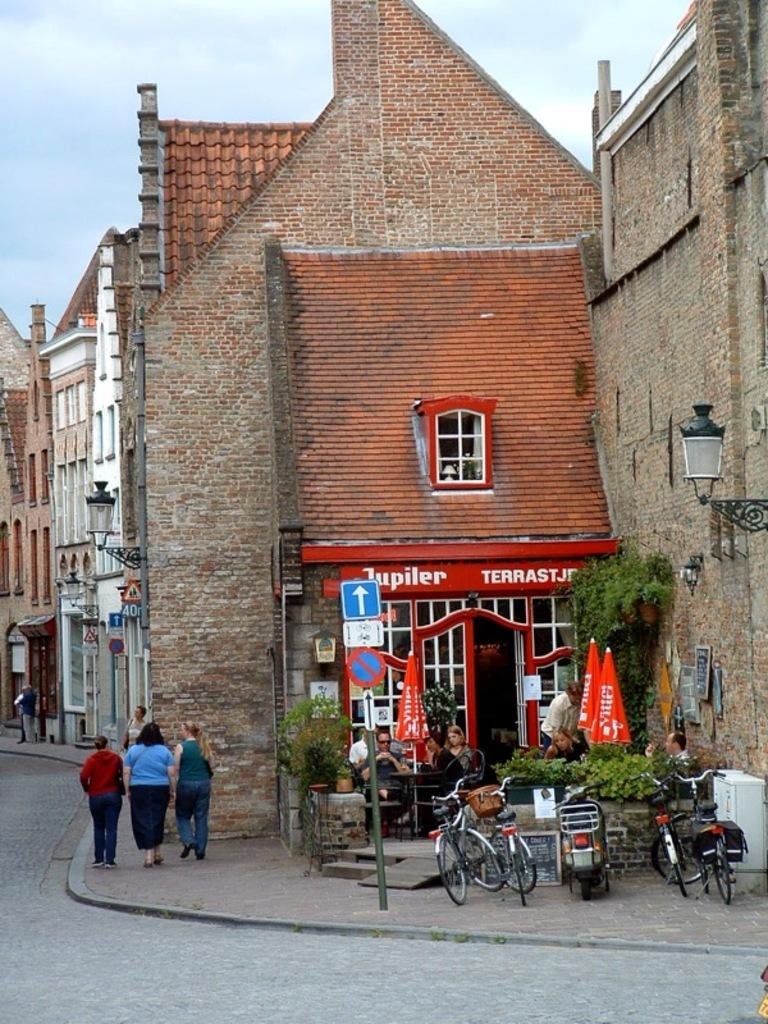Provide a one-sentence caption for the provided image. A quaint old building has a red awning advertising Jupiler. 